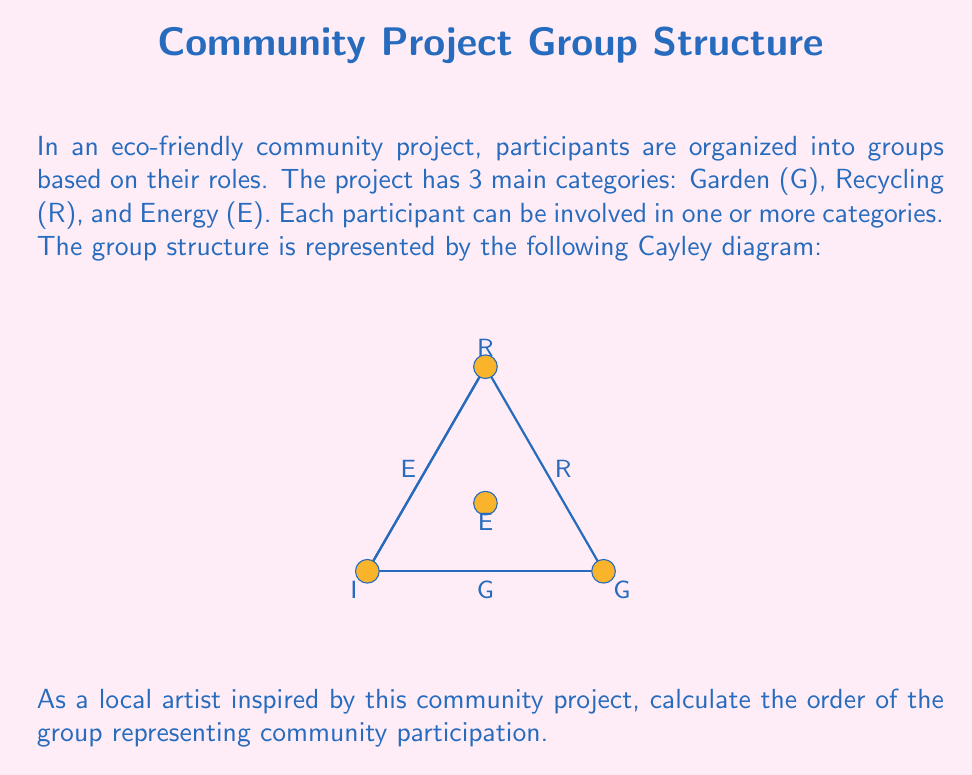Can you solve this math problem? To calculate the order of the group, we need to identify all unique elements in the group based on the given Cayley diagram. Let's analyze step-by-step:

1) From the diagram, we can see four labeled elements:
   - I (Identity)
   - G (Garden)
   - R (Recycling)
   - E (Energy)

2) The arrows in the diagram represent the group operations. Each arrow shows how one element transforms into another.

3) We can verify that this group is closed under its operation:
   - G * G = I
   - R * R = I
   - E * E = I
   - G * R = E
   - R * G = E
   - G * E = R
   - E * G = R
   - R * E = G
   - E * R = G

4) The group satisfies the properties of a group:
   - Closure: As shown in step 3
   - Associativity: Inherent in the diagram structure
   - Identity: I is the identity element
   - Inverse: Each element is its own inverse (G * G = R * R = E * E = I)

5) To find the order of the group, we count the number of unique elements:
   $|G| = |\{I, G, R, E\}| = 4$

Therefore, the order of the group representing community participation in this eco-friendly project is 4.
Answer: 4 